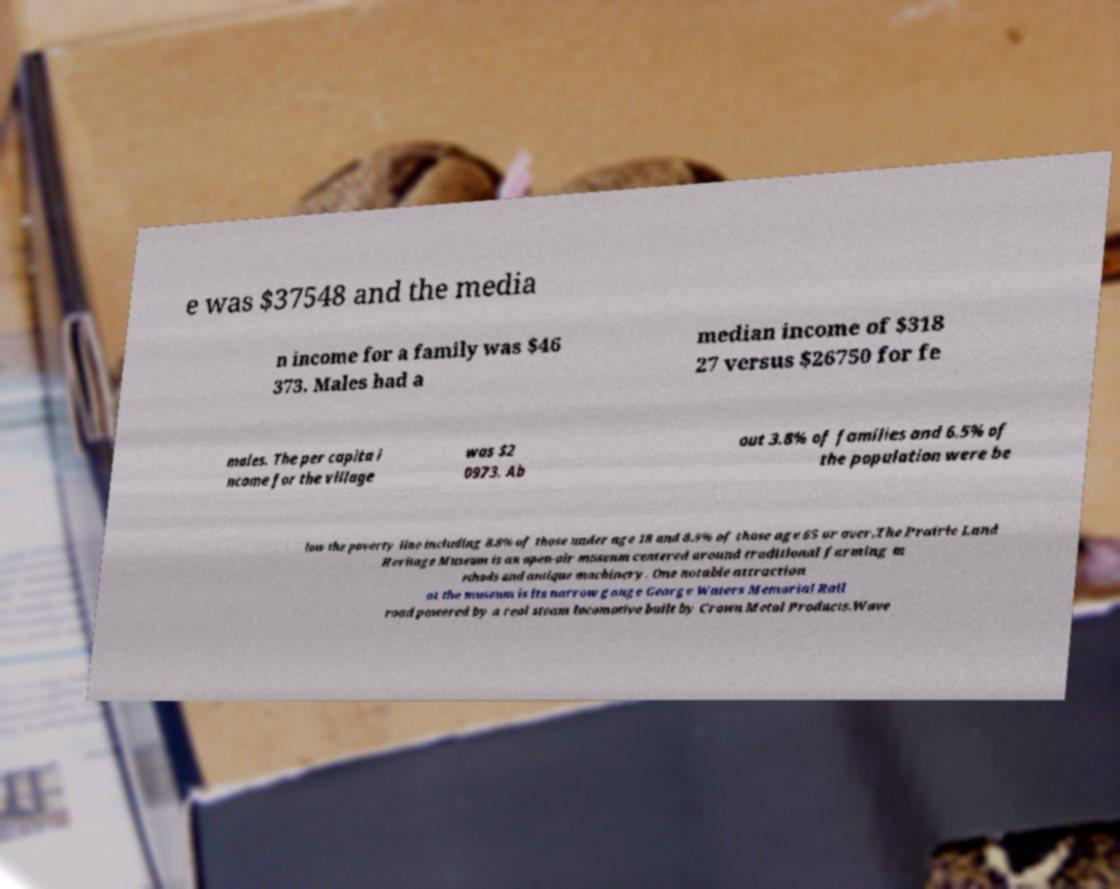Please identify and transcribe the text found in this image. e was $37548 and the media n income for a family was $46 373. Males had a median income of $318 27 versus $26750 for fe males. The per capita i ncome for the village was $2 0973. Ab out 3.8% of families and 6.5% of the population were be low the poverty line including 8.8% of those under age 18 and 8.9% of those age 65 or over.The Prairie Land Heritage Museum is an open-air museum centered around traditional farming m ethods and antique machinery. One notable attraction at the museum is its narrow gauge George Waters Memorial Rail road powered by a real steam locomotive built by Crown Metal Products.Wave 